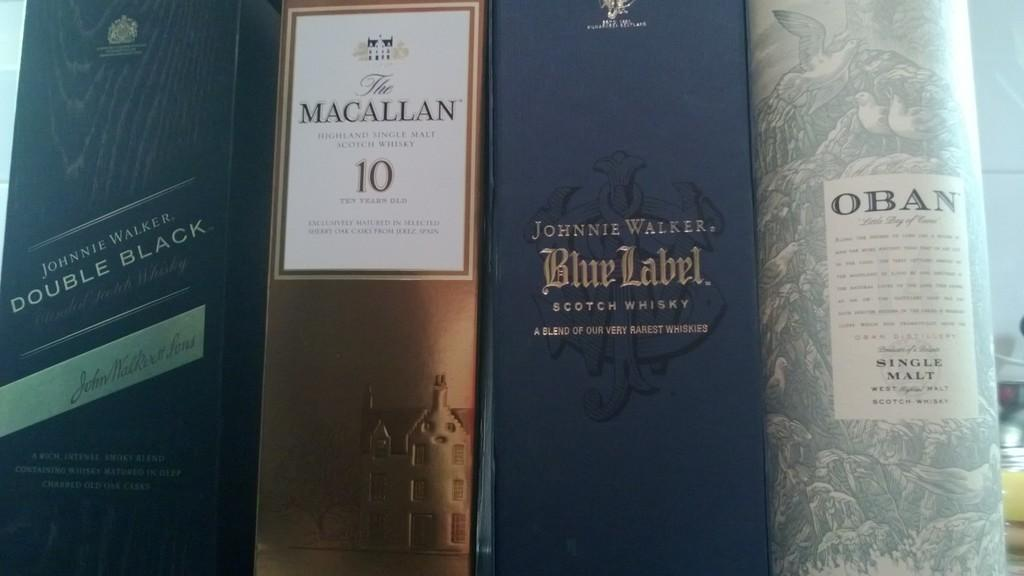<image>
Share a concise interpretation of the image provided. Johnnie Walker Blue Label box in between two other alcohol boxes. 